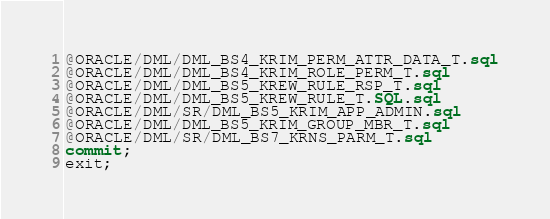<code> <loc_0><loc_0><loc_500><loc_500><_SQL_>@ORACLE/DML/DML_BS4_KRIM_PERM_ATTR_DATA_T.sql
@ORACLE/DML/DML_BS4_KRIM_ROLE_PERM_T.sql
@ORACLE/DML/DML_BS5_KREW_RULE_RSP_T.sql
@ORACLE/DML/DML_BS5_KREW_RULE_T.SQL.sql
@ORACLE/DML/SR/DML_BS5_KRIM_APP_ADMIN.sql
@ORACLE/DML/DML_BS5_KRIM_GROUP_MBR_T.sql
@ORACLE/DML/SR/DML_BS7_KRNS_PARM_T.sql
commit;
exit;
</code> 